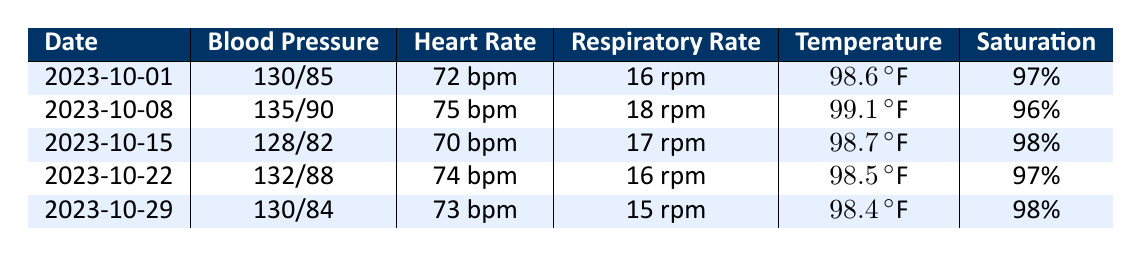What was the blood pressure on October 22, 2023? From the table, the blood pressure on October 22, 2023, is shown as 132/88.
Answer: 132/88 What was the heart rate on October 15, 2023? The heart rate for Mr. James Thompson on October 15, 2023, is recorded as 70 bpm.
Answer: 70 bpm Was Mr. James Thompson's respiratory rate ever above 18 rpm during the check-ups? Looking through the respiratory rates, the only value above 18 rpm occurs on October 8, 2023, at 18 rpm. Therefore, the answer is yes.
Answer: Yes What is the average temperature from all check-ups recorded in October? The temperatures are 98.6°F, 99.1°F, 98.7°F, 98.5°F, and 98.4°F. Adding these gives 493.3°F. Dividing by the 5 check-ups gives an average of 98.66°F.
Answer: 98.66°F On which date did Mr. James Thompson have the lowest heart rate? By examining the heart rate column, the lowest heart rate is 70 bpm occurring on October 15, 2023.
Answer: October 15, 2023 What change in blood pressure occurred from October 1 to October 29, 2023? The blood pressure changed from 130/85 on October 1 to 130/84 on October 29. The systolic remained the same while the diastolic decreased by 1.
Answer: No change in systolic; decreased diastolic by 1 Did Mr. James Thompson's oxygen saturation dip below 96% at any time? The table shows oxygen saturation values of 97% on October 1, 22, and 29, and 96% on October 8. Thus, on October 8, it was 96%, but never below that.
Answer: No What pattern can be seen in the heart rate observations over the weeks? The heart rates show a slight fluctuation but generally remain within a narrow range of 70 bpm to 75 bpm without significant upward or downward trends over the weeks.
Answer: Slight fluctuation around 70 to 75 bpm 